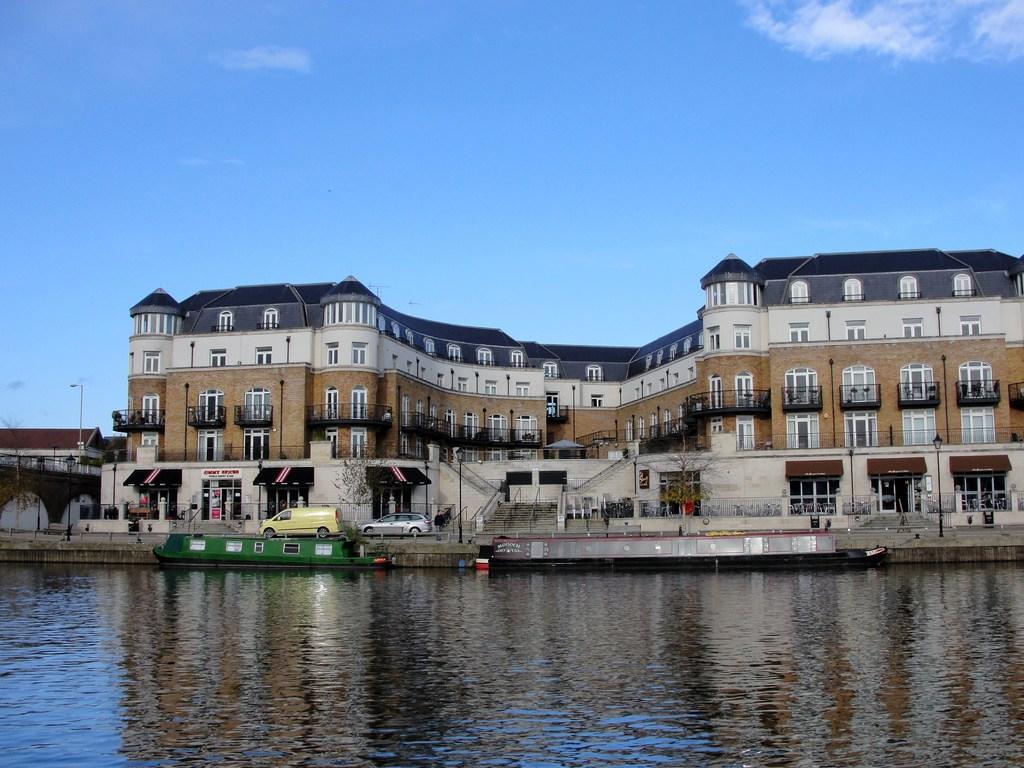Could you give a brief overview of what you see in this image? In this image I can see water in the front and on it I can see two boats. In the background I can see few vehicles, few buildings, number of poles, street lights, a board on the building, clouds and the sky. I can also see something is written on the board and in the center of the image I can see few trees. 